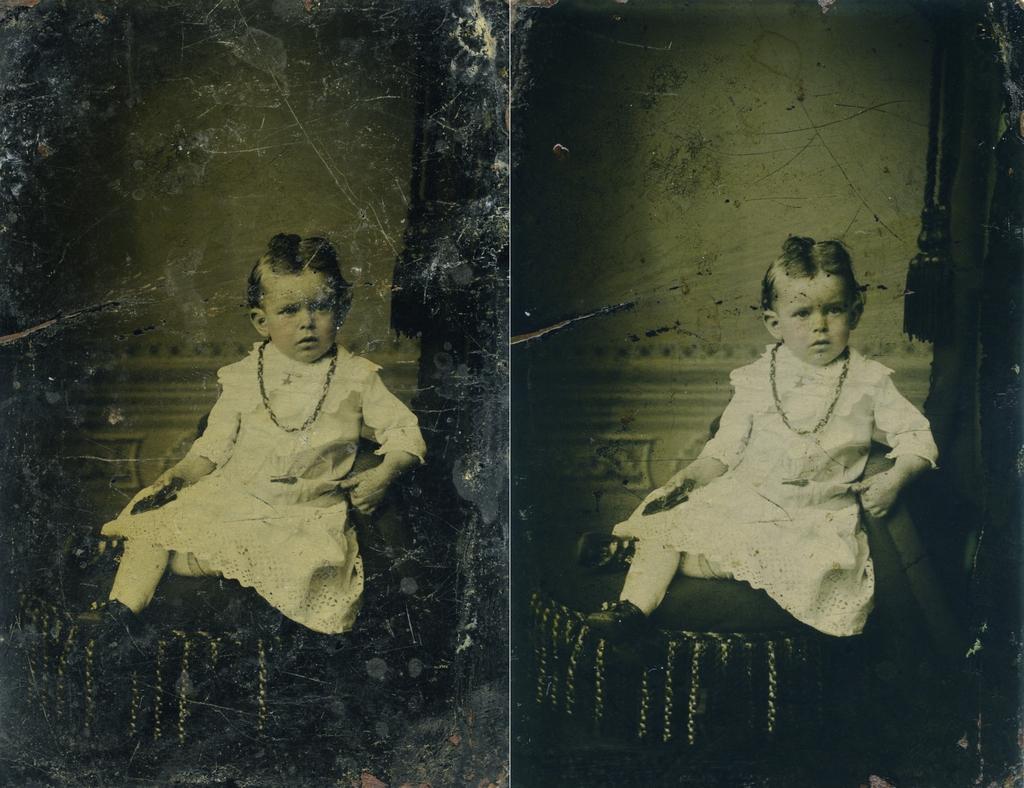Could you give a brief overview of what you see in this image? There are 2 images which are similar. A child is sitting wearing a white dress and a chain. 